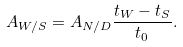Convert formula to latex. <formula><loc_0><loc_0><loc_500><loc_500>A _ { W / S } = A _ { N / D } \frac { t _ { W } - t _ { S } } { t _ { 0 } } .</formula> 